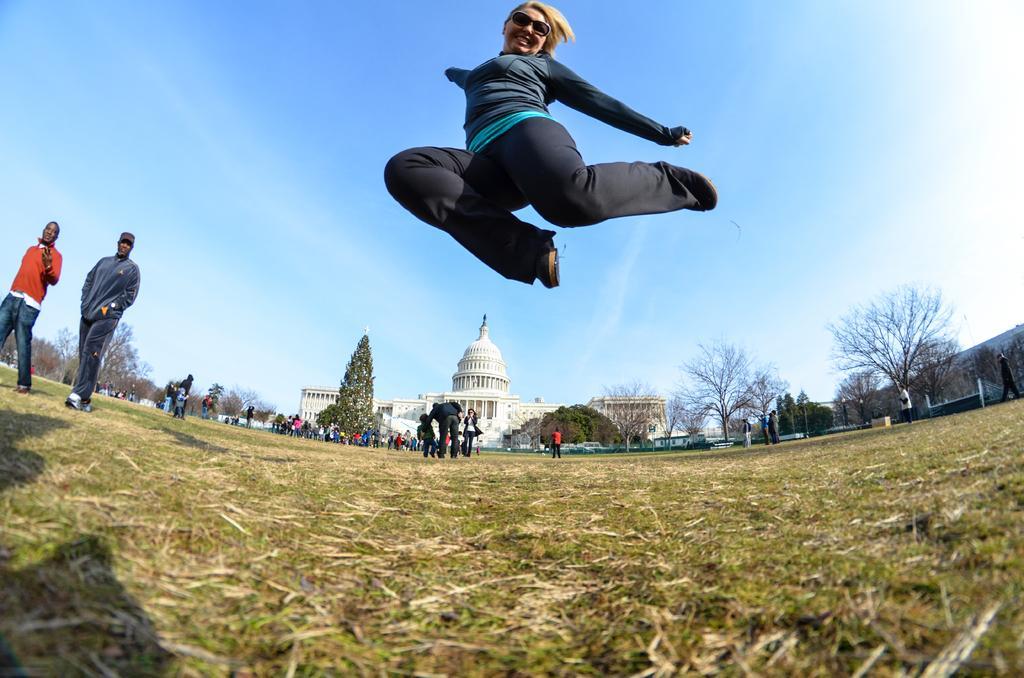Can you describe this image briefly? In this picture I can see a woman jumping, there are group of people standing, there are trees, there is a building, and in the background there is sky. 